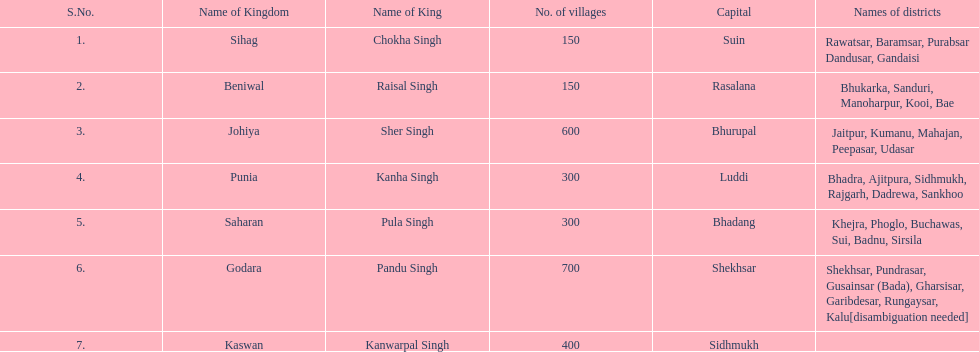What is the next realm mentioned after sihag? Beniwal. 